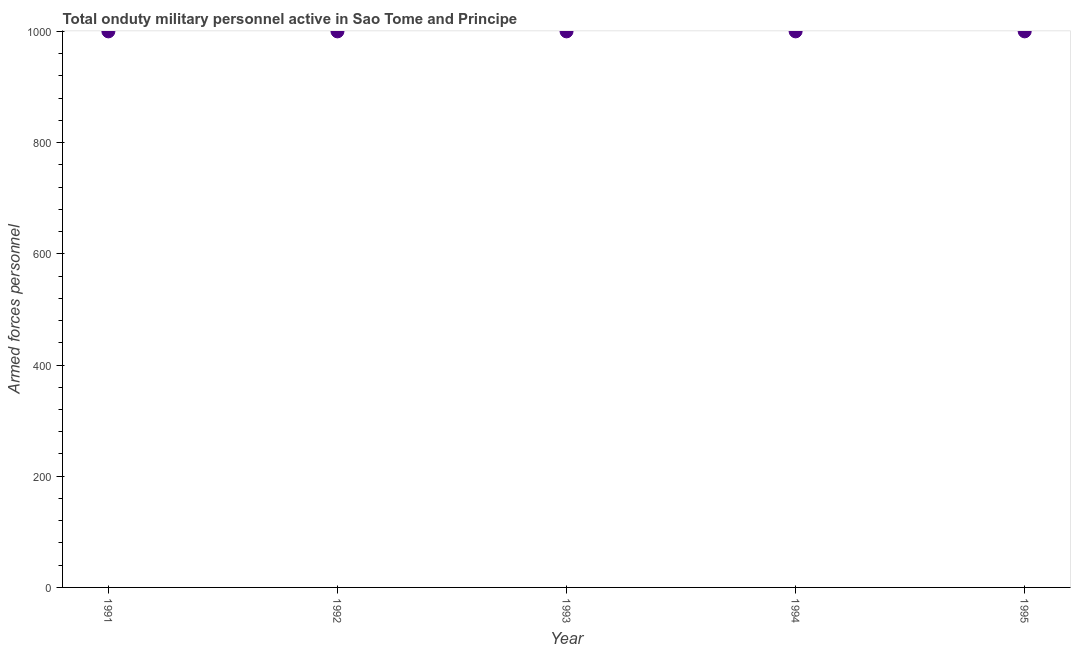What is the number of armed forces personnel in 1992?
Give a very brief answer. 1000. Across all years, what is the maximum number of armed forces personnel?
Provide a short and direct response. 1000. Across all years, what is the minimum number of armed forces personnel?
Your answer should be very brief. 1000. What is the sum of the number of armed forces personnel?
Provide a succinct answer. 5000. What is the difference between the number of armed forces personnel in 1991 and 1993?
Your answer should be compact. 0. In how many years, is the number of armed forces personnel greater than 480 ?
Keep it short and to the point. 5. Is the difference between the number of armed forces personnel in 1993 and 1994 greater than the difference between any two years?
Provide a succinct answer. Yes. Is the sum of the number of armed forces personnel in 1993 and 1995 greater than the maximum number of armed forces personnel across all years?
Offer a very short reply. Yes. What is the difference between the highest and the lowest number of armed forces personnel?
Offer a terse response. 0. In how many years, is the number of armed forces personnel greater than the average number of armed forces personnel taken over all years?
Give a very brief answer. 0. What is the difference between two consecutive major ticks on the Y-axis?
Keep it short and to the point. 200. Are the values on the major ticks of Y-axis written in scientific E-notation?
Keep it short and to the point. No. Does the graph contain grids?
Keep it short and to the point. No. What is the title of the graph?
Offer a terse response. Total onduty military personnel active in Sao Tome and Principe. What is the label or title of the Y-axis?
Provide a short and direct response. Armed forces personnel. What is the Armed forces personnel in 1991?
Ensure brevity in your answer.  1000. What is the Armed forces personnel in 1994?
Offer a very short reply. 1000. What is the Armed forces personnel in 1995?
Offer a terse response. 1000. What is the difference between the Armed forces personnel in 1991 and 1992?
Keep it short and to the point. 0. What is the difference between the Armed forces personnel in 1991 and 1993?
Keep it short and to the point. 0. What is the difference between the Armed forces personnel in 1991 and 1994?
Ensure brevity in your answer.  0. What is the difference between the Armed forces personnel in 1994 and 1995?
Offer a very short reply. 0. What is the ratio of the Armed forces personnel in 1991 to that in 1992?
Provide a succinct answer. 1. What is the ratio of the Armed forces personnel in 1991 to that in 1993?
Provide a succinct answer. 1. What is the ratio of the Armed forces personnel in 1991 to that in 1994?
Offer a terse response. 1. What is the ratio of the Armed forces personnel in 1992 to that in 1993?
Your response must be concise. 1. What is the ratio of the Armed forces personnel in 1993 to that in 1995?
Provide a short and direct response. 1. What is the ratio of the Armed forces personnel in 1994 to that in 1995?
Your response must be concise. 1. 